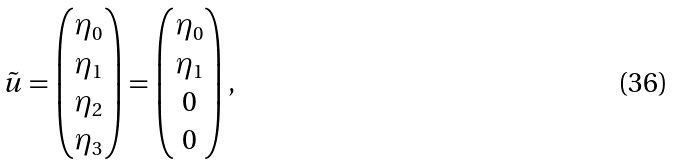Convert formula to latex. <formula><loc_0><loc_0><loc_500><loc_500>\tilde { u } & = \begin{pmatrix} \eta _ { 0 } \\ \eta _ { 1 } \\ \eta _ { 2 } \\ \eta _ { 3 } \end{pmatrix} = \begin{pmatrix} \eta _ { 0 } \\ \eta _ { 1 } \\ 0 \\ 0 \end{pmatrix} ,</formula> 